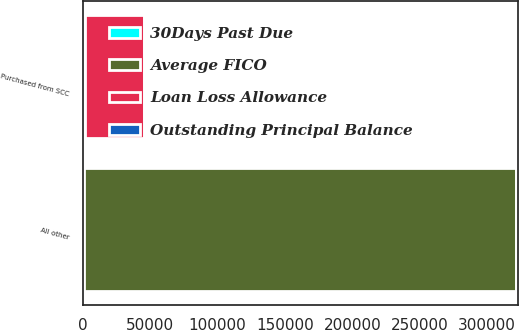Convert chart to OTSL. <chart><loc_0><loc_0><loc_500><loc_500><stacked_bar_chart><ecel><fcel>Purchased from SCC<fcel>All other<nl><fcel>Average FICO<fcel>721<fcel>320751<nl><fcel>Loan Loss Allowance<fcel>43769<fcel>1632<nl><fcel>Outstanding Principal Balance<fcel>17.53<fcel>2.07<nl><fcel>30Days Past Due<fcel>664<fcel>721<nl></chart> 